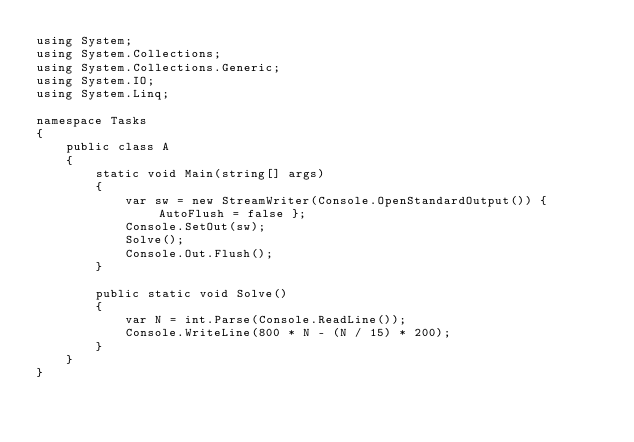Convert code to text. <code><loc_0><loc_0><loc_500><loc_500><_C#_>using System;
using System.Collections;
using System.Collections.Generic;
using System.IO;
using System.Linq;

namespace Tasks
{
    public class A
    {
        static void Main(string[] args)
        {
            var sw = new StreamWriter(Console.OpenStandardOutput()) { AutoFlush = false };
            Console.SetOut(sw);
            Solve();
            Console.Out.Flush();
        }

        public static void Solve()
        {
            var N = int.Parse(Console.ReadLine());
            Console.WriteLine(800 * N - (N / 15) * 200);
        }
    }
}
</code> 